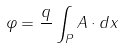Convert formula to latex. <formula><loc_0><loc_0><loc_500><loc_500>\varphi = \frac { q } { } \int _ { P } A \cdot d x</formula> 